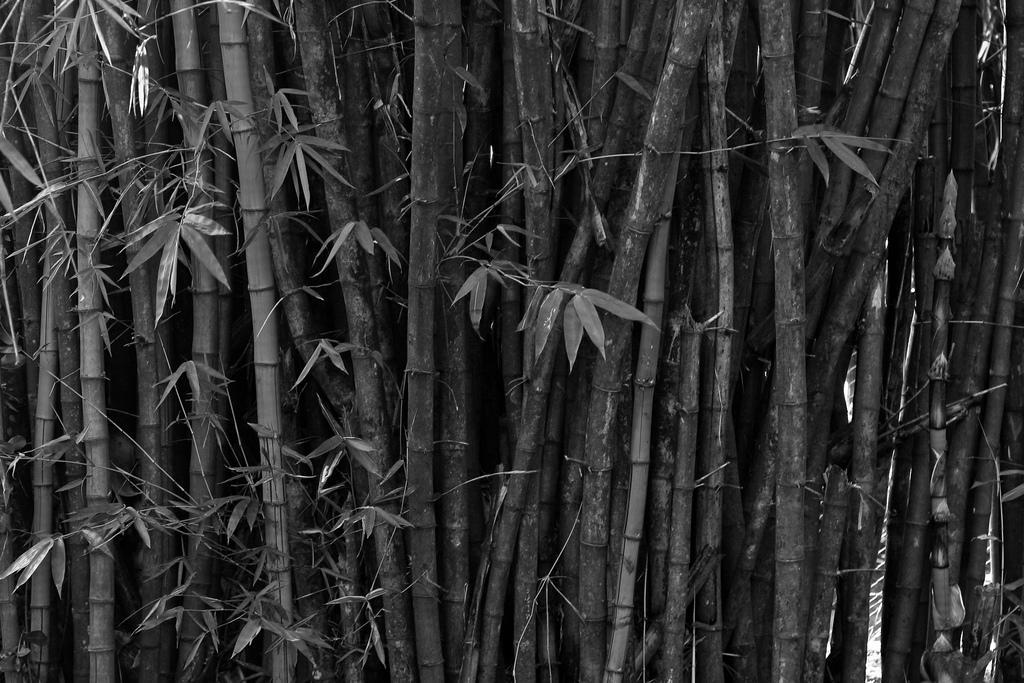In one or two sentences, can you explain what this image depicts? The picture consists of bamboo and leaves. 